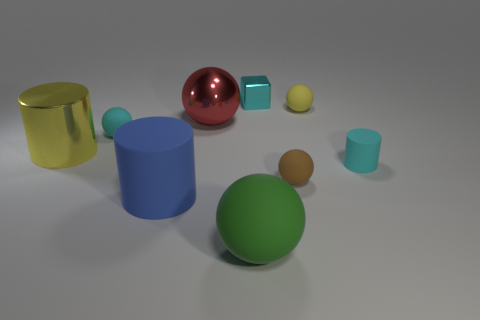Can you tell me which objects seem to follow a cylindrical shape? Certainly, there are three objects with cylindrical shapes in the image. The blue object in the center is a solid cylinder, whereas the yellow object on the left and the smaller cyan object on the right are both cylindrical cups, differentiated by their open tops. 